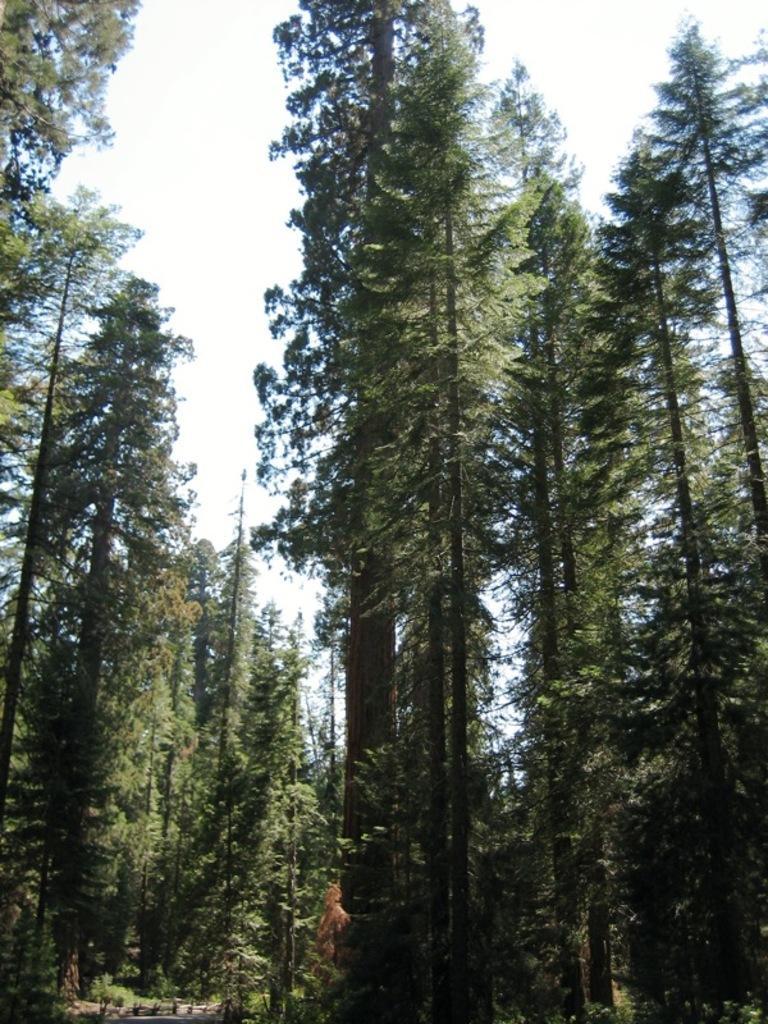In one or two sentences, can you explain what this image depicts? In the image we can see some trees. Behind the trees there is sky. 